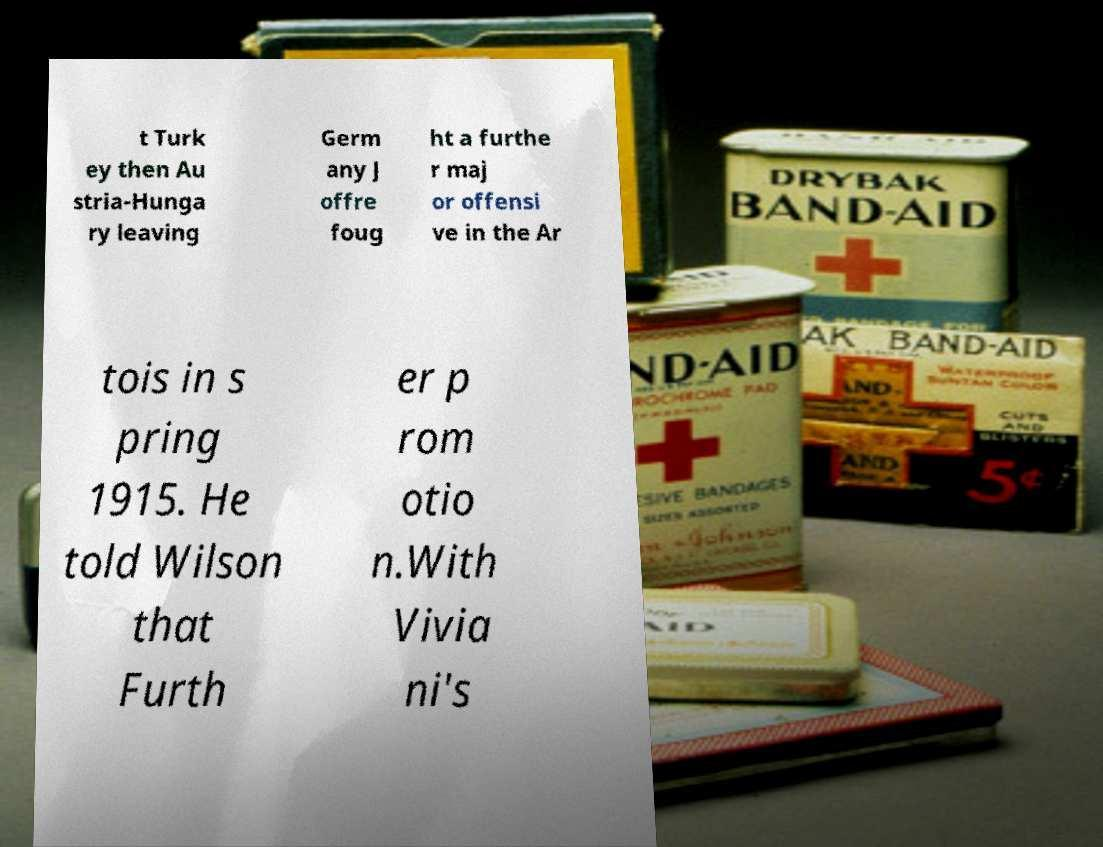Please identify and transcribe the text found in this image. t Turk ey then Au stria-Hunga ry leaving Germ any J offre foug ht a furthe r maj or offensi ve in the Ar tois in s pring 1915. He told Wilson that Furth er p rom otio n.With Vivia ni's 